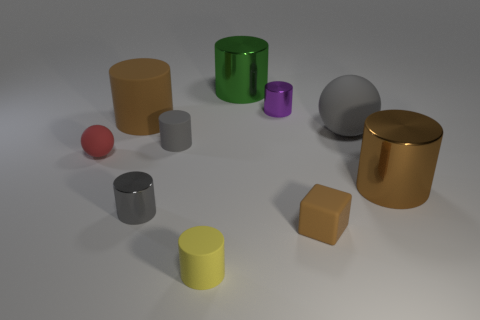How many gray cylinders must be subtracted to get 1 gray cylinders? 1 Subtract all brown matte cylinders. How many cylinders are left? 6 Add 9 small yellow rubber things. How many small yellow rubber things are left? 10 Add 3 large green cylinders. How many large green cylinders exist? 4 Subtract all gray spheres. How many spheres are left? 1 Subtract 1 green cylinders. How many objects are left? 9 Subtract all blocks. How many objects are left? 9 Subtract 1 cubes. How many cubes are left? 0 Subtract all cyan spheres. Subtract all purple blocks. How many spheres are left? 2 Subtract all blue cubes. How many green balls are left? 0 